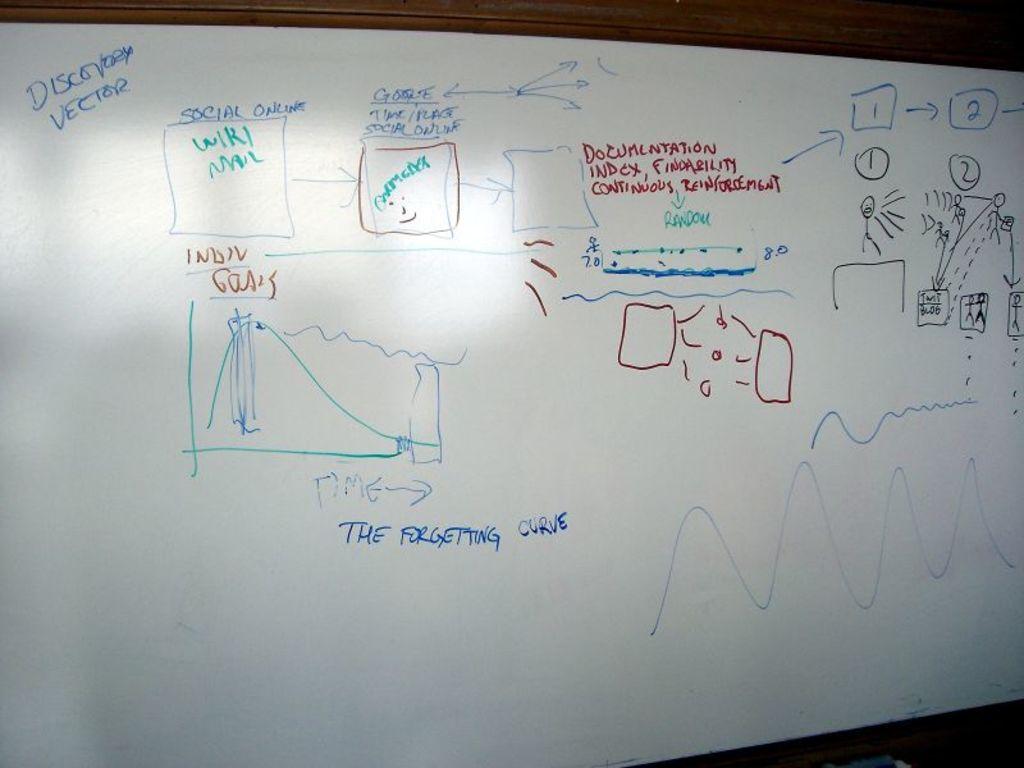What kind of curve?
Offer a very short reply. The forgetting curve. 